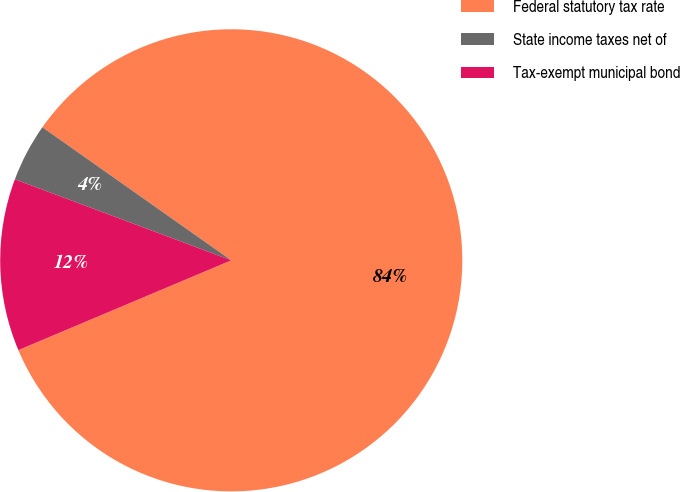<chart> <loc_0><loc_0><loc_500><loc_500><pie_chart><fcel>Federal statutory tax rate<fcel>State income taxes net of<fcel>Tax-exempt municipal bond<nl><fcel>83.87%<fcel>4.07%<fcel>12.05%<nl></chart> 